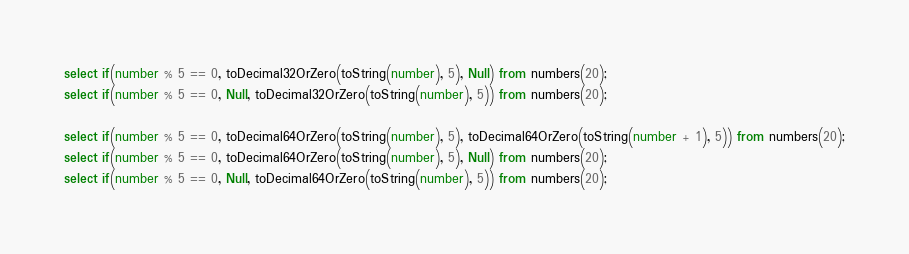<code> <loc_0><loc_0><loc_500><loc_500><_SQL_>select if(number % 5 == 0, toDecimal32OrZero(toString(number), 5), Null) from numbers(20);
select if(number % 5 == 0, Null, toDecimal32OrZero(toString(number), 5)) from numbers(20);

select if(number % 5 == 0, toDecimal64OrZero(toString(number), 5), toDecimal64OrZero(toString(number + 1), 5)) from numbers(20);
select if(number % 5 == 0, toDecimal64OrZero(toString(number), 5), Null) from numbers(20);
select if(number % 5 == 0, Null, toDecimal64OrZero(toString(number), 5)) from numbers(20);
</code> 